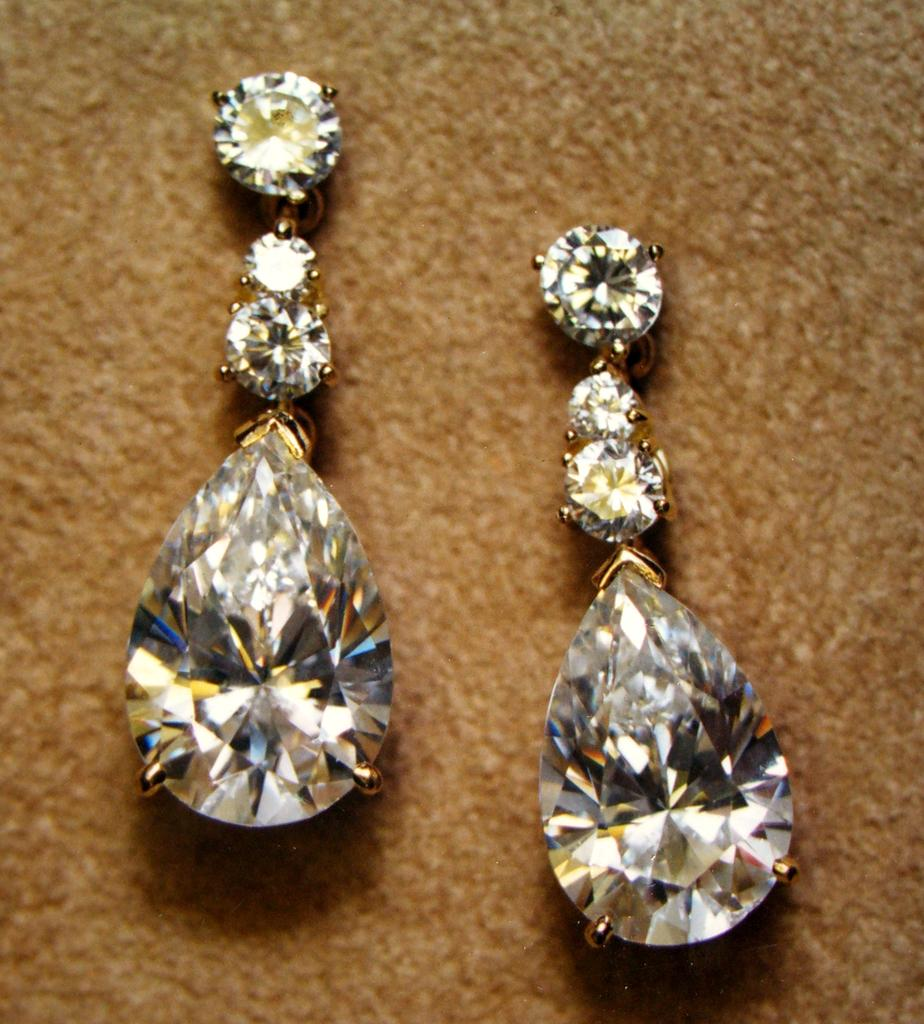What type of jewelry is present in the image? There are two diamond earrings in the image. Where are the diamond earrings located? The diamond earrings are placed on a table or carpet. What flavor of ice cream is being served in the diamond earrings? There is no ice cream or serving in the diamond earrings; they are simply earrings. 